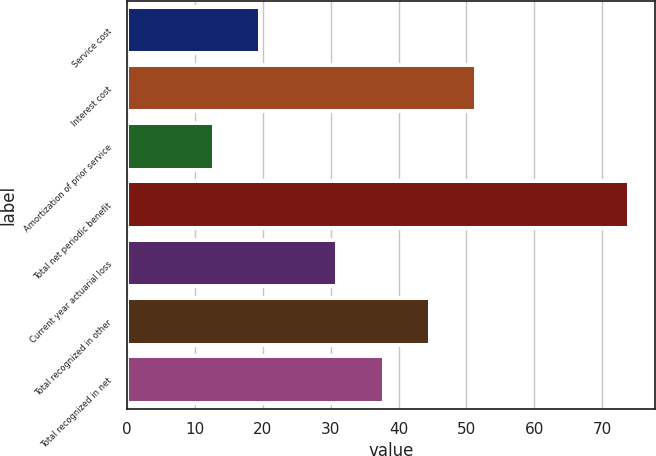Convert chart. <chart><loc_0><loc_0><loc_500><loc_500><bar_chart><fcel>Service cost<fcel>Interest cost<fcel>Amortization of prior service<fcel>Total net periodic benefit<fcel>Current year actuarial loss<fcel>Total recognized in other<fcel>Total recognized in net<nl><fcel>19.6<fcel>51.4<fcel>12.8<fcel>74<fcel>31<fcel>44.6<fcel>37.8<nl></chart> 